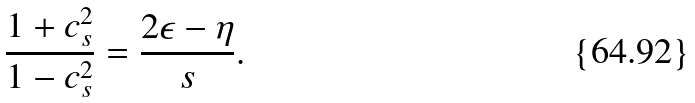Convert formula to latex. <formula><loc_0><loc_0><loc_500><loc_500>\frac { 1 + c _ { s } ^ { 2 } } { 1 - c _ { s } ^ { 2 } } = \frac { 2 \epsilon - \eta } { s } .</formula> 